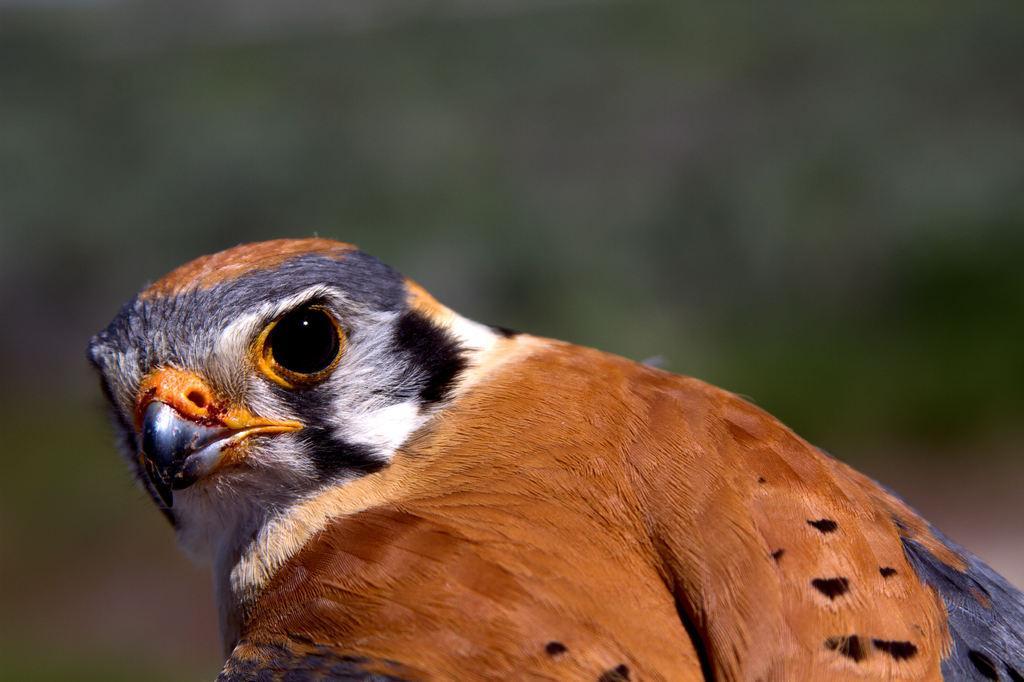In one or two sentences, can you explain what this image depicts? In this image we can see a bird which is in black, grey, white and brown color. 